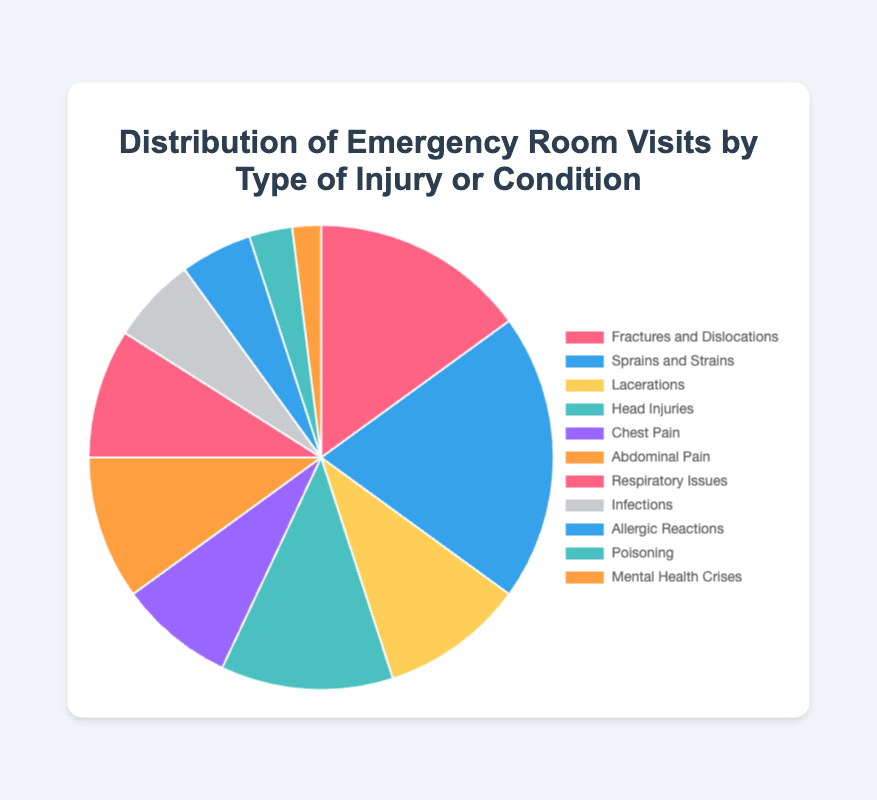Which type of injury or condition has the highest percentage of emergency room visits? The highest percentage value in the pie chart is for 'Sprains and Strains' which is 20%.
Answer: Sprains and Strains Which type of injury or condition has the lowest representation in emergency room visits? The lowest percentage value in the pie chart is for 'Mental Health Crises' which is 2%.
Answer: Mental Health Crises What is the combined percentage of emergency room visits for 'Respiratory Issues', 'Infections', and 'Allergic Reactions'? Add the percentages of 'Respiratory Issues' (9%), 'Infections' (6%), and 'Allergic Reactions' (5%). The combined percentage is 9 + 6 + 5 = 20%.
Answer: 20% How does the percentage of visits for 'Chest Pain' compare to 'Head Injuries'? The percentage for 'Chest Pain' is 8% and for 'Head Injuries' is 12%. 'Head Injuries' has a higher percentage than 'Chest Pain'.
Answer: Head Injuries What is the percentage difference between 'Fractures and Dislocations' and 'Lacerations'? Subtract the percentage of 'Lacerations' (10%) from the percentage of 'Fractures and Dislocations' (15%). The difference is 15 - 10 = 5%.
Answer: 5% Which categories have a combined percentage of 20% or more? Adding percentages of various categories, 'Sprains and Strains' is 20% alone. 'Fractures and Dislocations' (15%) and 'Lacerations' (10%) together are 25%.
Answer: Sprains and Strains, Fractures and Dislocations + Lacerations What percentage of emergency room visits are due to pain-related conditions ('Chest Pain' and 'Abdominal Pain')? Add the percentages of 'Chest Pain' (8%) and 'Abdominal Pain' (10%). The combined percentage is 8 + 10 = 18%.
Answer: 18% How do the combined percentages of 'Fractures and Dislocations', 'Sprains and Strains', and 'Lacerations' compare to the rest of the conditions? The combined percentage of 'Fractures and Dislocations' (15%), 'Sprains and Strains' (20%), and 'Lacerations' (10%) is 15 + 20 + 10 = 45%. Since the total must add to 100%, the rest of the conditions sum up to 100 - 45 = 55%.
Answer: 45% vs 55% Which condition has a slightly lower percentage than 'Head Injuries'? 'Head Injuries' is 12%. The condition with the next highest percentage after this is 'Respiratory Issues' with 9%.
Answer: Respiratory Issues Given the conditions 'Infections' and 'Poisoning', what’s the combined percentage and how does it compare to 'Head Injuries'? The combined percentage of 'Infections' (6%) and 'Poisoning' (3%) is 6 + 3 = 9%. 'Head Injuries' have a higher percentage at 12%.
Answer: 9%, Head Injuries higher 